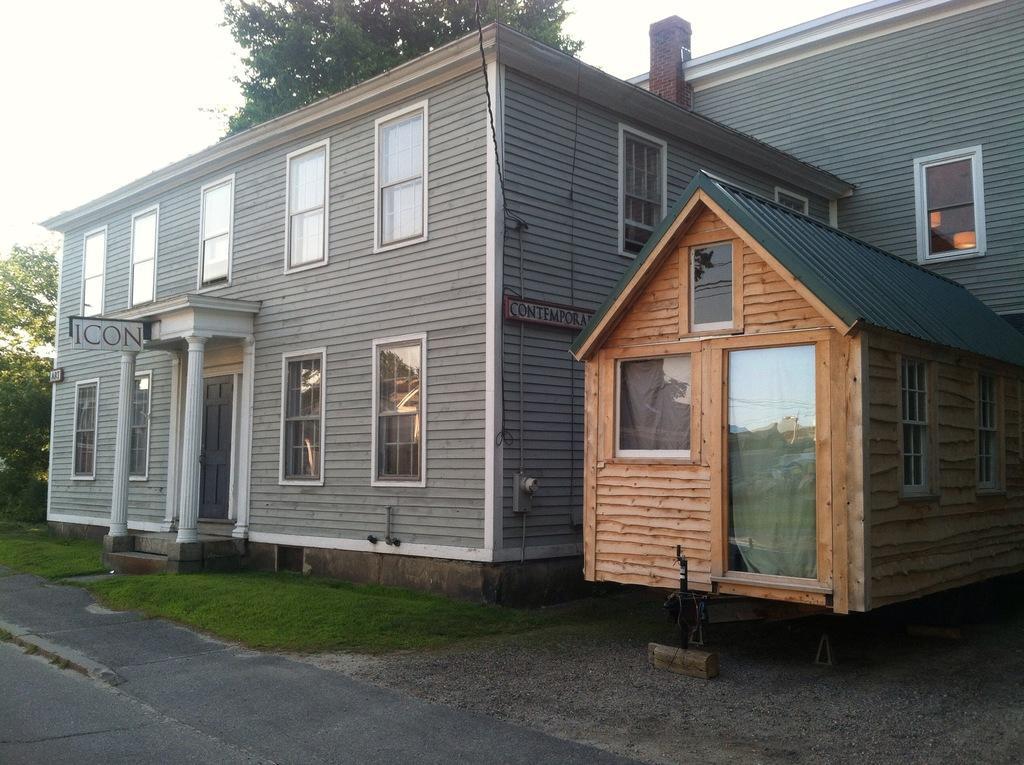In one or two sentences, can you explain what this image depicts? In this picture we can observe two houses. There is a white color board on the left side. In front of these houses we can observe some grass on the ground. In the background there are trees and a sky. 